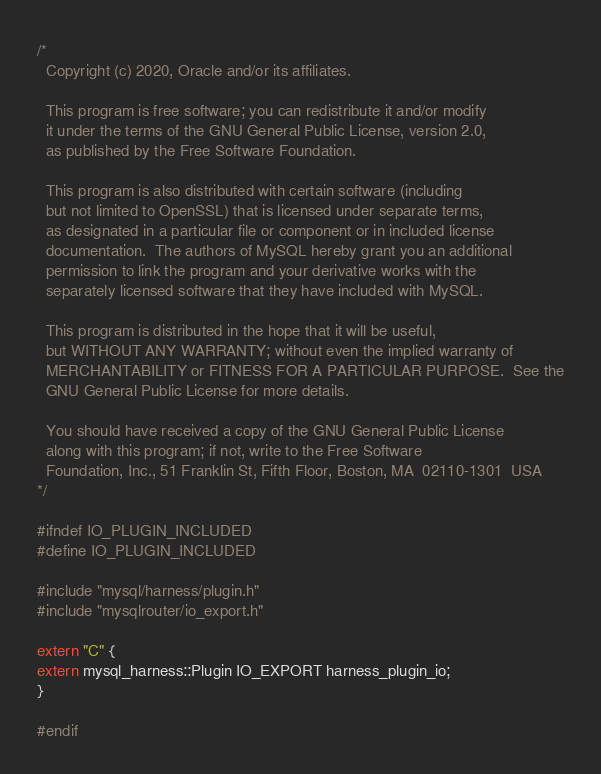<code> <loc_0><loc_0><loc_500><loc_500><_C_>/*
  Copyright (c) 2020, Oracle and/or its affiliates.

  This program is free software; you can redistribute it and/or modify
  it under the terms of the GNU General Public License, version 2.0,
  as published by the Free Software Foundation.

  This program is also distributed with certain software (including
  but not limited to OpenSSL) that is licensed under separate terms,
  as designated in a particular file or component or in included license
  documentation.  The authors of MySQL hereby grant you an additional
  permission to link the program and your derivative works with the
  separately licensed software that they have included with MySQL.

  This program is distributed in the hope that it will be useful,
  but WITHOUT ANY WARRANTY; without even the implied warranty of
  MERCHANTABILITY or FITNESS FOR A PARTICULAR PURPOSE.  See the
  GNU General Public License for more details.

  You should have received a copy of the GNU General Public License
  along with this program; if not, write to the Free Software
  Foundation, Inc., 51 Franklin St, Fifth Floor, Boston, MA  02110-1301  USA
*/

#ifndef IO_PLUGIN_INCLUDED
#define IO_PLUGIN_INCLUDED

#include "mysql/harness/plugin.h"
#include "mysqlrouter/io_export.h"

extern "C" {
extern mysql_harness::Plugin IO_EXPORT harness_plugin_io;
}

#endif
</code> 